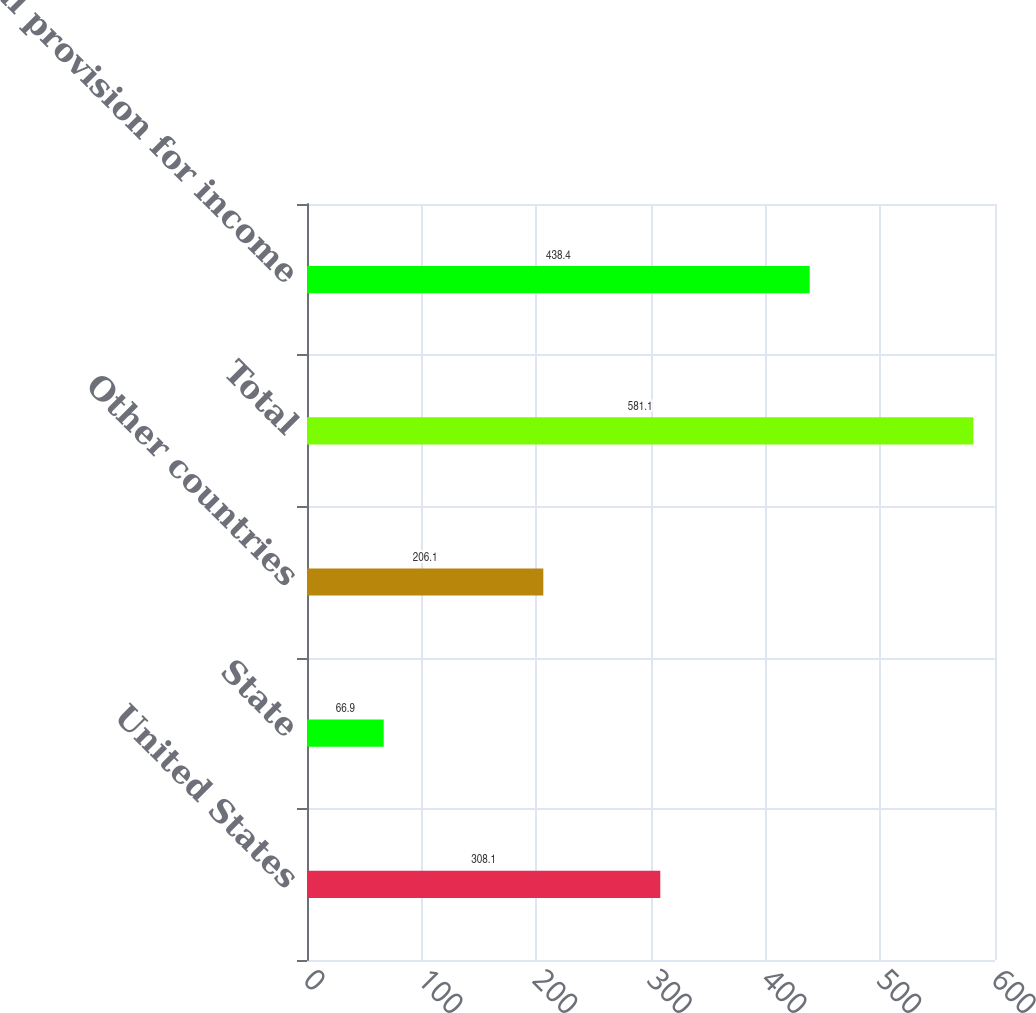<chart> <loc_0><loc_0><loc_500><loc_500><bar_chart><fcel>United States<fcel>State<fcel>Other countries<fcel>Total<fcel>Total provision for income<nl><fcel>308.1<fcel>66.9<fcel>206.1<fcel>581.1<fcel>438.4<nl></chart> 